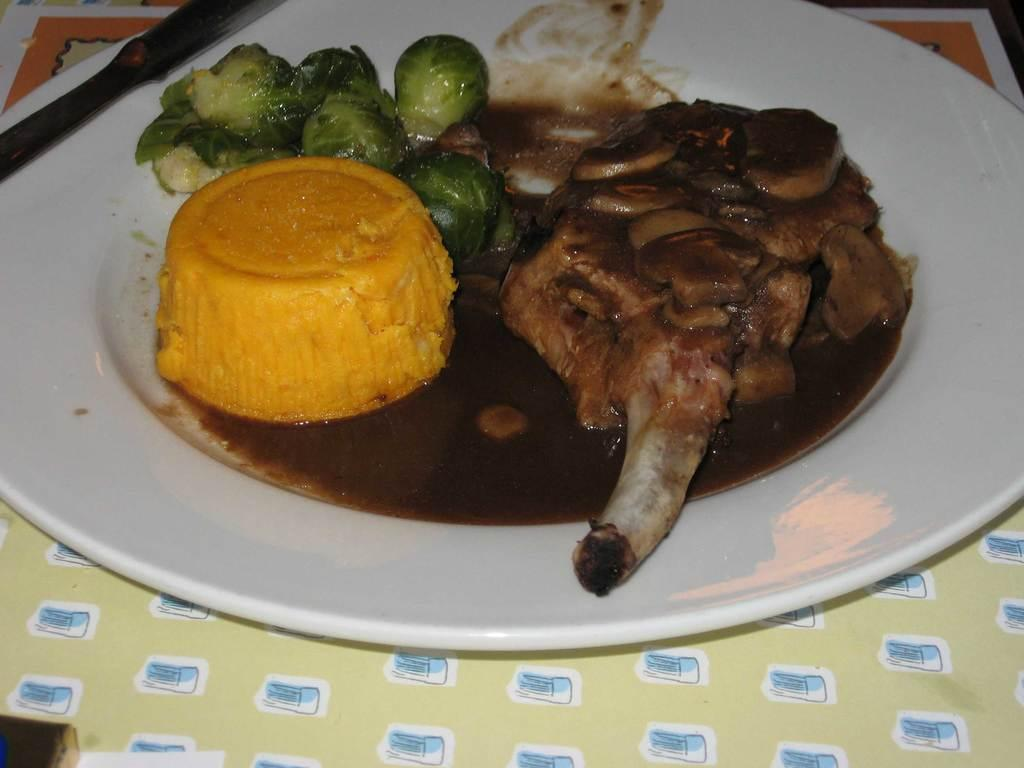What is on the plate that is visible in the image? There are food items in a plate. Where is the plate with food items located? The plate with food items is placed on a table. What type of paste is being used to fix the bikes in the image? There is no paste or bikes present in the image; it features a plate with food items placed on a table. 